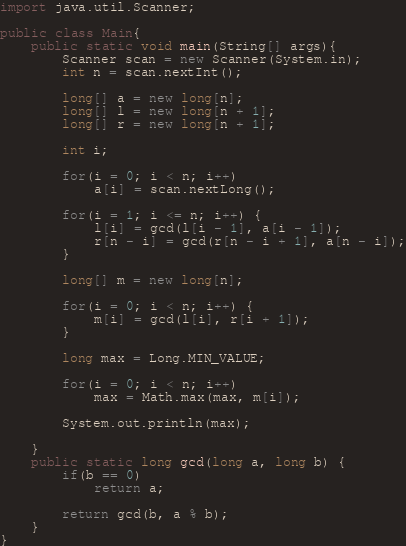<code> <loc_0><loc_0><loc_500><loc_500><_Java_>import java.util.Scanner;

public class Main{
	public static void main(String[] args){
		Scanner scan = new Scanner(System.in);
		int n = scan.nextInt();

		long[] a = new long[n];
		long[] l = new long[n + 1];
		long[] r = new long[n + 1];

		int i;

		for(i = 0; i < n; i++)
			a[i] = scan.nextLong();

		for(i = 1; i <= n; i++) {
			l[i] = gcd(l[i - 1], a[i - 1]);
			r[n - i] = gcd(r[n - i + 1], a[n - i]);
		}

		long[] m = new long[n];

		for(i = 0; i < n; i++) {
			m[i] = gcd(l[i], r[i + 1]);
		}

		long max = Long.MIN_VALUE;

		for(i = 0; i < n; i++)
			max = Math.max(max, m[i]);

		System.out.println(max);

	}
	public static long gcd(long a, long b) {
		if(b == 0)
			return a;

		return gcd(b, a % b);
	}
}
</code> 